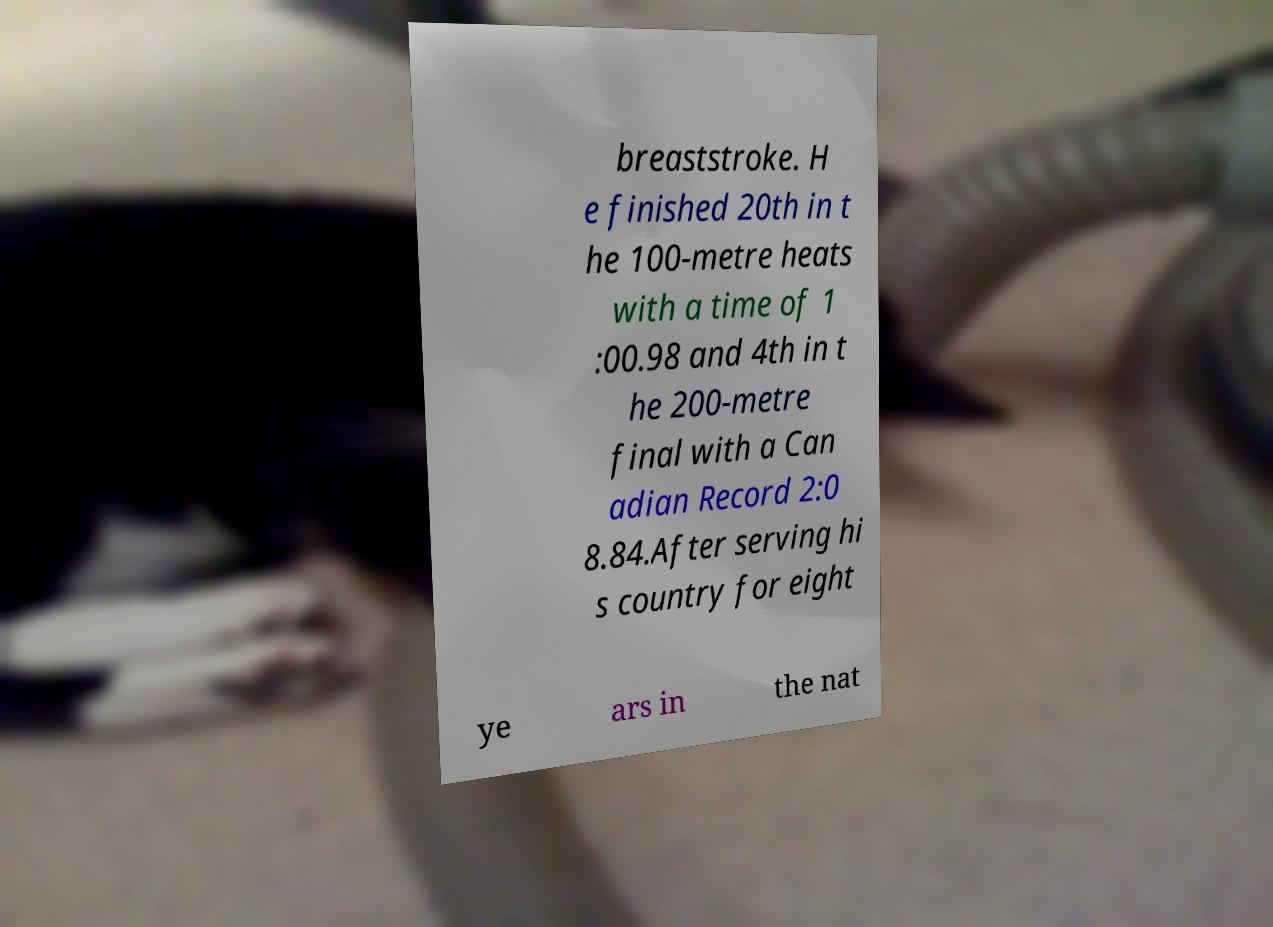What messages or text are displayed in this image? I need them in a readable, typed format. breaststroke. H e finished 20th in t he 100-metre heats with a time of 1 :00.98 and 4th in t he 200-metre final with a Can adian Record 2:0 8.84.After serving hi s country for eight ye ars in the nat 